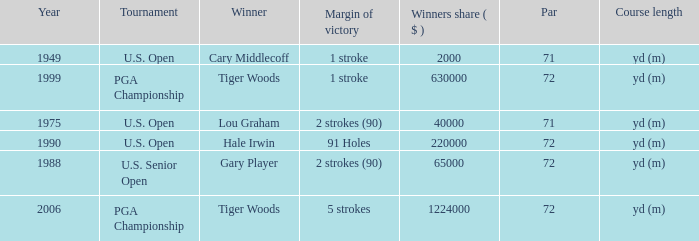When cary middlecoff is the winner how many pars are there? 1.0. 